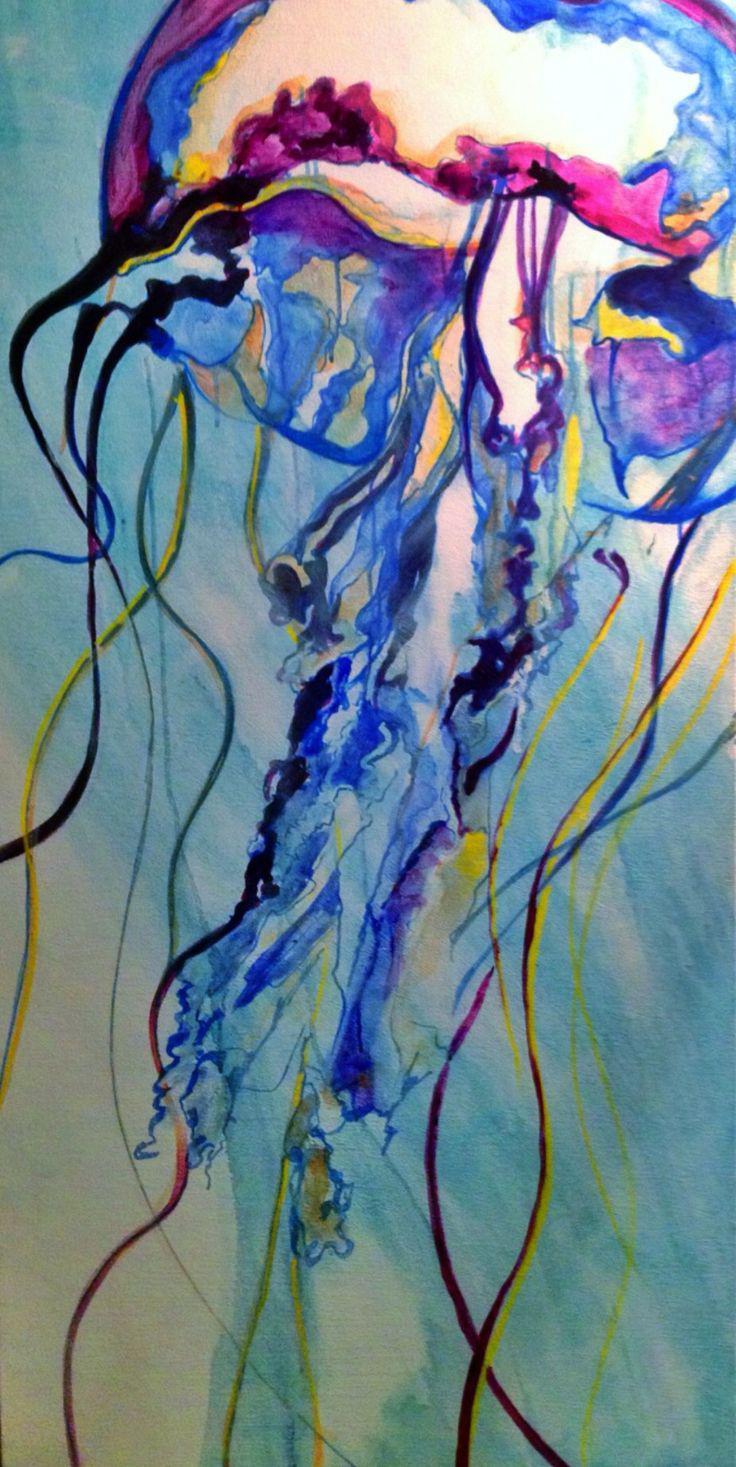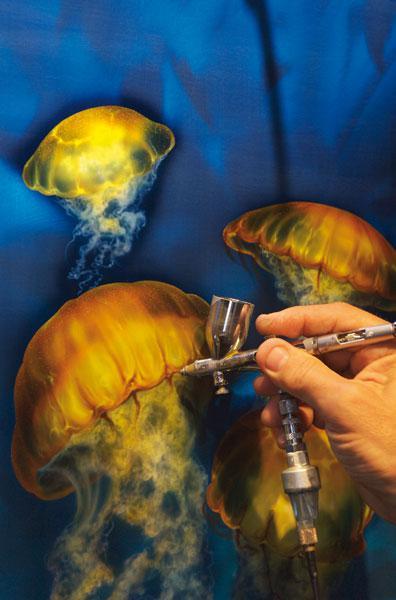The first image is the image on the left, the second image is the image on the right. For the images displayed, is the sentence "An image shows a hand at the right painting a jellyfish scene." factually correct? Answer yes or no. Yes. The first image is the image on the left, the second image is the image on the right. Given the left and right images, does the statement "A person is painting a picture of jellyfish in one of the images." hold true? Answer yes or no. Yes. 